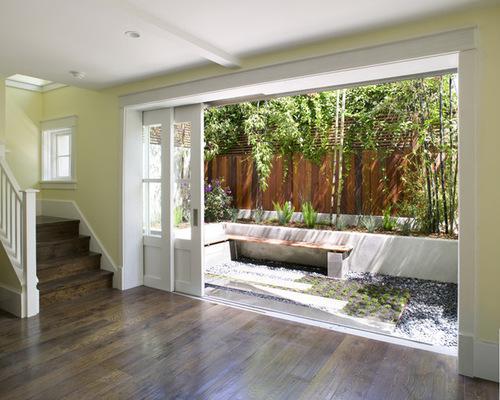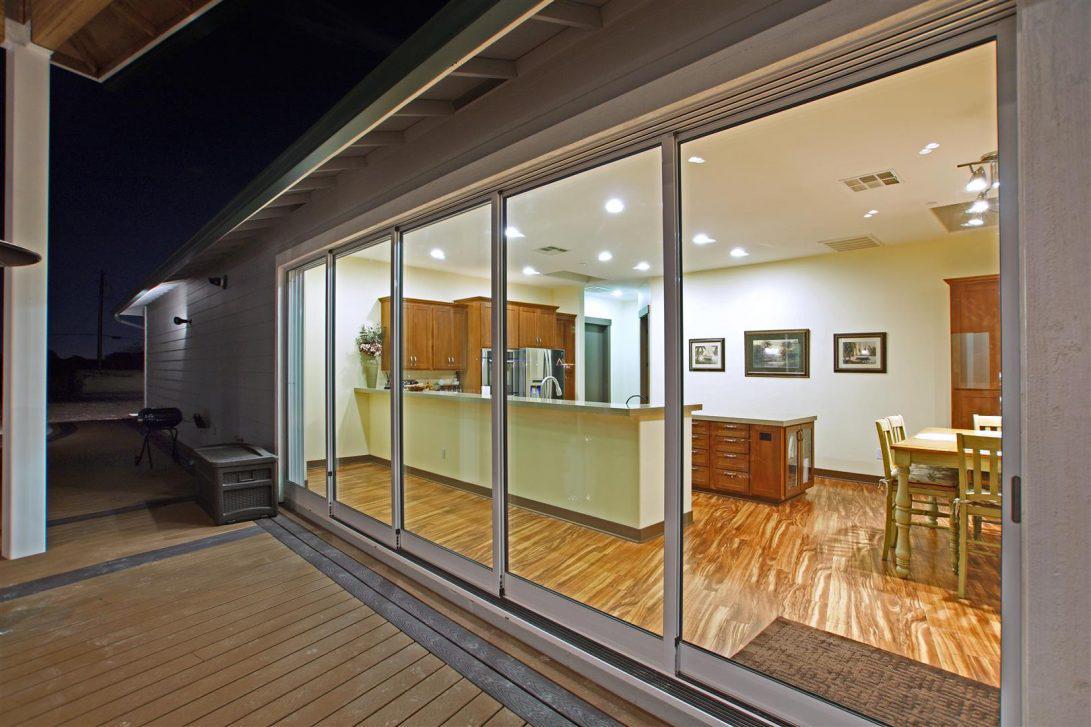The first image is the image on the left, the second image is the image on the right. For the images displayed, is the sentence "At least one door has white trim." factually correct? Answer yes or no. Yes. The first image is the image on the left, the second image is the image on the right. Considering the images on both sides, is "There are two exterior views of open glass panels that open to the outside." valid? Answer yes or no. No. 